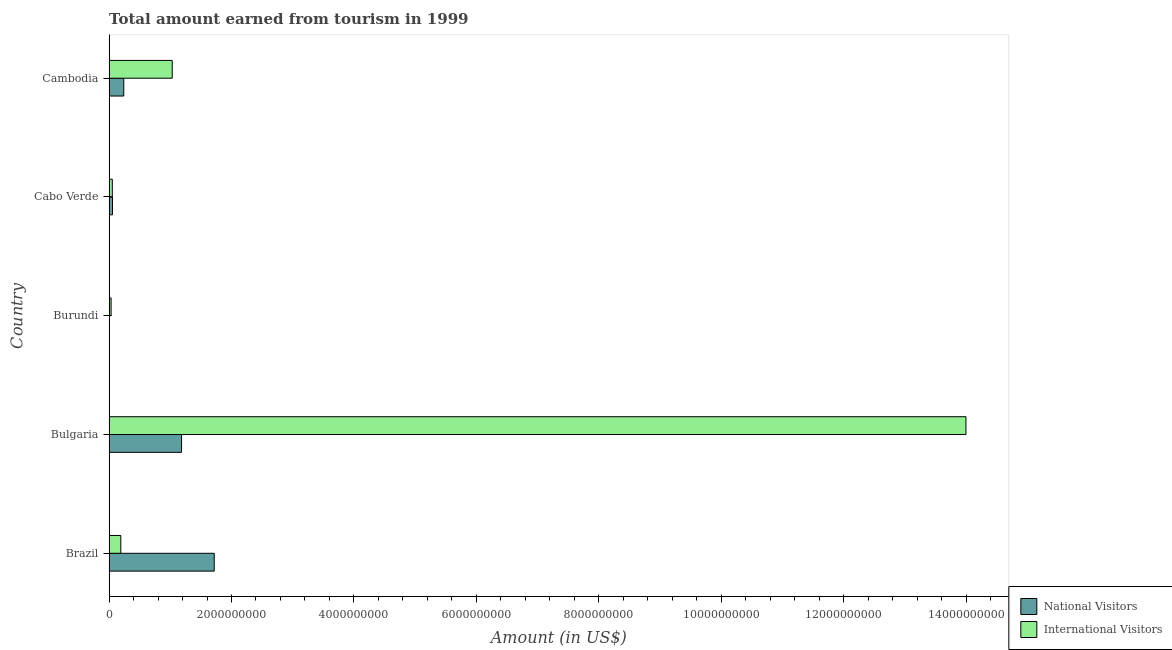How many groups of bars are there?
Give a very brief answer. 5. Are the number of bars per tick equal to the number of legend labels?
Give a very brief answer. Yes. How many bars are there on the 5th tick from the top?
Offer a very short reply. 2. What is the label of the 3rd group of bars from the top?
Provide a short and direct response. Burundi. What is the amount earned from national visitors in Burundi?
Offer a very short reply. 1.20e+06. Across all countries, what is the maximum amount earned from national visitors?
Make the answer very short. 1.72e+09. Across all countries, what is the minimum amount earned from national visitors?
Keep it short and to the point. 1.20e+06. In which country was the amount earned from national visitors minimum?
Your answer should be very brief. Burundi. What is the total amount earned from international visitors in the graph?
Make the answer very short. 1.53e+1. What is the difference between the amount earned from international visitors in Brazil and that in Bulgaria?
Provide a short and direct response. -1.38e+1. What is the difference between the amount earned from international visitors in Bulgaria and the amount earned from national visitors in Cambodia?
Make the answer very short. 1.38e+1. What is the average amount earned from international visitors per country?
Make the answer very short. 3.06e+09. What is the difference between the amount earned from national visitors and amount earned from international visitors in Burundi?
Make the answer very short. -3.18e+07. In how many countries, is the amount earned from international visitors greater than 6400000000 US$?
Give a very brief answer. 1. What is the ratio of the amount earned from international visitors in Burundi to that in Cabo Verde?
Make the answer very short. 0.62. What is the difference between the highest and the second highest amount earned from national visitors?
Your response must be concise. 5.34e+08. What is the difference between the highest and the lowest amount earned from national visitors?
Offer a very short reply. 1.72e+09. Is the sum of the amount earned from national visitors in Bulgaria and Cabo Verde greater than the maximum amount earned from international visitors across all countries?
Your answer should be compact. No. What does the 1st bar from the top in Cambodia represents?
Provide a succinct answer. International Visitors. What does the 2nd bar from the bottom in Brazil represents?
Your answer should be compact. International Visitors. How many countries are there in the graph?
Make the answer very short. 5. What is the difference between two consecutive major ticks on the X-axis?
Offer a very short reply. 2.00e+09. How many legend labels are there?
Make the answer very short. 2. What is the title of the graph?
Provide a short and direct response. Total amount earned from tourism in 1999. What is the label or title of the Y-axis?
Ensure brevity in your answer.  Country. What is the Amount (in US$) in National Visitors in Brazil?
Your answer should be very brief. 1.72e+09. What is the Amount (in US$) in International Visitors in Brazil?
Your answer should be very brief. 1.92e+08. What is the Amount (in US$) in National Visitors in Bulgaria?
Your response must be concise. 1.18e+09. What is the Amount (in US$) of International Visitors in Bulgaria?
Offer a terse response. 1.40e+1. What is the Amount (in US$) in National Visitors in Burundi?
Offer a terse response. 1.20e+06. What is the Amount (in US$) of International Visitors in Burundi?
Offer a terse response. 3.30e+07. What is the Amount (in US$) of National Visitors in Cabo Verde?
Provide a short and direct response. 5.60e+07. What is the Amount (in US$) in International Visitors in Cabo Verde?
Offer a terse response. 5.30e+07. What is the Amount (in US$) in National Visitors in Cambodia?
Give a very brief answer. 2.40e+08. What is the Amount (in US$) of International Visitors in Cambodia?
Provide a short and direct response. 1.03e+09. Across all countries, what is the maximum Amount (in US$) of National Visitors?
Make the answer very short. 1.72e+09. Across all countries, what is the maximum Amount (in US$) of International Visitors?
Offer a very short reply. 1.40e+1. Across all countries, what is the minimum Amount (in US$) in National Visitors?
Make the answer very short. 1.20e+06. Across all countries, what is the minimum Amount (in US$) of International Visitors?
Your response must be concise. 3.30e+07. What is the total Amount (in US$) of National Visitors in the graph?
Provide a short and direct response. 3.20e+09. What is the total Amount (in US$) in International Visitors in the graph?
Ensure brevity in your answer.  1.53e+1. What is the difference between the Amount (in US$) in National Visitors in Brazil and that in Bulgaria?
Make the answer very short. 5.34e+08. What is the difference between the Amount (in US$) of International Visitors in Brazil and that in Bulgaria?
Offer a very short reply. -1.38e+1. What is the difference between the Amount (in US$) of National Visitors in Brazil and that in Burundi?
Keep it short and to the point. 1.72e+09. What is the difference between the Amount (in US$) in International Visitors in Brazil and that in Burundi?
Offer a very short reply. 1.59e+08. What is the difference between the Amount (in US$) in National Visitors in Brazil and that in Cabo Verde?
Your answer should be very brief. 1.66e+09. What is the difference between the Amount (in US$) in International Visitors in Brazil and that in Cabo Verde?
Offer a terse response. 1.39e+08. What is the difference between the Amount (in US$) of National Visitors in Brazil and that in Cambodia?
Your answer should be very brief. 1.48e+09. What is the difference between the Amount (in US$) of International Visitors in Brazil and that in Cambodia?
Keep it short and to the point. -8.40e+08. What is the difference between the Amount (in US$) of National Visitors in Bulgaria and that in Burundi?
Give a very brief answer. 1.18e+09. What is the difference between the Amount (in US$) of International Visitors in Bulgaria and that in Burundi?
Offer a very short reply. 1.40e+1. What is the difference between the Amount (in US$) of National Visitors in Bulgaria and that in Cabo Verde?
Your answer should be very brief. 1.13e+09. What is the difference between the Amount (in US$) of International Visitors in Bulgaria and that in Cabo Verde?
Make the answer very short. 1.39e+1. What is the difference between the Amount (in US$) in National Visitors in Bulgaria and that in Cambodia?
Provide a succinct answer. 9.44e+08. What is the difference between the Amount (in US$) in International Visitors in Bulgaria and that in Cambodia?
Your answer should be compact. 1.30e+1. What is the difference between the Amount (in US$) of National Visitors in Burundi and that in Cabo Verde?
Give a very brief answer. -5.48e+07. What is the difference between the Amount (in US$) of International Visitors in Burundi and that in Cabo Verde?
Provide a short and direct response. -2.00e+07. What is the difference between the Amount (in US$) in National Visitors in Burundi and that in Cambodia?
Your response must be concise. -2.39e+08. What is the difference between the Amount (in US$) in International Visitors in Burundi and that in Cambodia?
Your answer should be compact. -9.99e+08. What is the difference between the Amount (in US$) of National Visitors in Cabo Verde and that in Cambodia?
Your answer should be compact. -1.84e+08. What is the difference between the Amount (in US$) in International Visitors in Cabo Verde and that in Cambodia?
Offer a very short reply. -9.79e+08. What is the difference between the Amount (in US$) of National Visitors in Brazil and the Amount (in US$) of International Visitors in Bulgaria?
Ensure brevity in your answer.  -1.23e+1. What is the difference between the Amount (in US$) of National Visitors in Brazil and the Amount (in US$) of International Visitors in Burundi?
Make the answer very short. 1.68e+09. What is the difference between the Amount (in US$) in National Visitors in Brazil and the Amount (in US$) in International Visitors in Cabo Verde?
Give a very brief answer. 1.66e+09. What is the difference between the Amount (in US$) in National Visitors in Brazil and the Amount (in US$) in International Visitors in Cambodia?
Provide a short and direct response. 6.86e+08. What is the difference between the Amount (in US$) of National Visitors in Bulgaria and the Amount (in US$) of International Visitors in Burundi?
Ensure brevity in your answer.  1.15e+09. What is the difference between the Amount (in US$) in National Visitors in Bulgaria and the Amount (in US$) in International Visitors in Cabo Verde?
Offer a very short reply. 1.13e+09. What is the difference between the Amount (in US$) in National Visitors in Bulgaria and the Amount (in US$) in International Visitors in Cambodia?
Offer a very short reply. 1.52e+08. What is the difference between the Amount (in US$) in National Visitors in Burundi and the Amount (in US$) in International Visitors in Cabo Verde?
Your answer should be very brief. -5.18e+07. What is the difference between the Amount (in US$) of National Visitors in Burundi and the Amount (in US$) of International Visitors in Cambodia?
Ensure brevity in your answer.  -1.03e+09. What is the difference between the Amount (in US$) in National Visitors in Cabo Verde and the Amount (in US$) in International Visitors in Cambodia?
Keep it short and to the point. -9.76e+08. What is the average Amount (in US$) of National Visitors per country?
Make the answer very short. 6.40e+08. What is the average Amount (in US$) of International Visitors per country?
Provide a succinct answer. 3.06e+09. What is the difference between the Amount (in US$) of National Visitors and Amount (in US$) of International Visitors in Brazil?
Offer a terse response. 1.53e+09. What is the difference between the Amount (in US$) of National Visitors and Amount (in US$) of International Visitors in Bulgaria?
Make the answer very short. -1.28e+1. What is the difference between the Amount (in US$) of National Visitors and Amount (in US$) of International Visitors in Burundi?
Your response must be concise. -3.18e+07. What is the difference between the Amount (in US$) in National Visitors and Amount (in US$) in International Visitors in Cambodia?
Your answer should be very brief. -7.92e+08. What is the ratio of the Amount (in US$) of National Visitors in Brazil to that in Bulgaria?
Your response must be concise. 1.45. What is the ratio of the Amount (in US$) in International Visitors in Brazil to that in Bulgaria?
Make the answer very short. 0.01. What is the ratio of the Amount (in US$) of National Visitors in Brazil to that in Burundi?
Provide a succinct answer. 1431.67. What is the ratio of the Amount (in US$) of International Visitors in Brazil to that in Burundi?
Your answer should be very brief. 5.82. What is the ratio of the Amount (in US$) in National Visitors in Brazil to that in Cabo Verde?
Provide a short and direct response. 30.68. What is the ratio of the Amount (in US$) of International Visitors in Brazil to that in Cabo Verde?
Offer a terse response. 3.62. What is the ratio of the Amount (in US$) of National Visitors in Brazil to that in Cambodia?
Your answer should be compact. 7.16. What is the ratio of the Amount (in US$) of International Visitors in Brazil to that in Cambodia?
Provide a short and direct response. 0.19. What is the ratio of the Amount (in US$) of National Visitors in Bulgaria to that in Burundi?
Provide a short and direct response. 986.67. What is the ratio of the Amount (in US$) in International Visitors in Bulgaria to that in Burundi?
Offer a very short reply. 424.21. What is the ratio of the Amount (in US$) of National Visitors in Bulgaria to that in Cabo Verde?
Make the answer very short. 21.14. What is the ratio of the Amount (in US$) of International Visitors in Bulgaria to that in Cabo Verde?
Keep it short and to the point. 264.13. What is the ratio of the Amount (in US$) in National Visitors in Bulgaria to that in Cambodia?
Offer a very short reply. 4.93. What is the ratio of the Amount (in US$) in International Visitors in Bulgaria to that in Cambodia?
Your answer should be compact. 13.56. What is the ratio of the Amount (in US$) in National Visitors in Burundi to that in Cabo Verde?
Your response must be concise. 0.02. What is the ratio of the Amount (in US$) of International Visitors in Burundi to that in Cabo Verde?
Provide a succinct answer. 0.62. What is the ratio of the Amount (in US$) of National Visitors in Burundi to that in Cambodia?
Your response must be concise. 0.01. What is the ratio of the Amount (in US$) in International Visitors in Burundi to that in Cambodia?
Provide a succinct answer. 0.03. What is the ratio of the Amount (in US$) in National Visitors in Cabo Verde to that in Cambodia?
Your answer should be very brief. 0.23. What is the ratio of the Amount (in US$) in International Visitors in Cabo Verde to that in Cambodia?
Make the answer very short. 0.05. What is the difference between the highest and the second highest Amount (in US$) in National Visitors?
Give a very brief answer. 5.34e+08. What is the difference between the highest and the second highest Amount (in US$) of International Visitors?
Offer a terse response. 1.30e+1. What is the difference between the highest and the lowest Amount (in US$) in National Visitors?
Your response must be concise. 1.72e+09. What is the difference between the highest and the lowest Amount (in US$) in International Visitors?
Your answer should be very brief. 1.40e+1. 